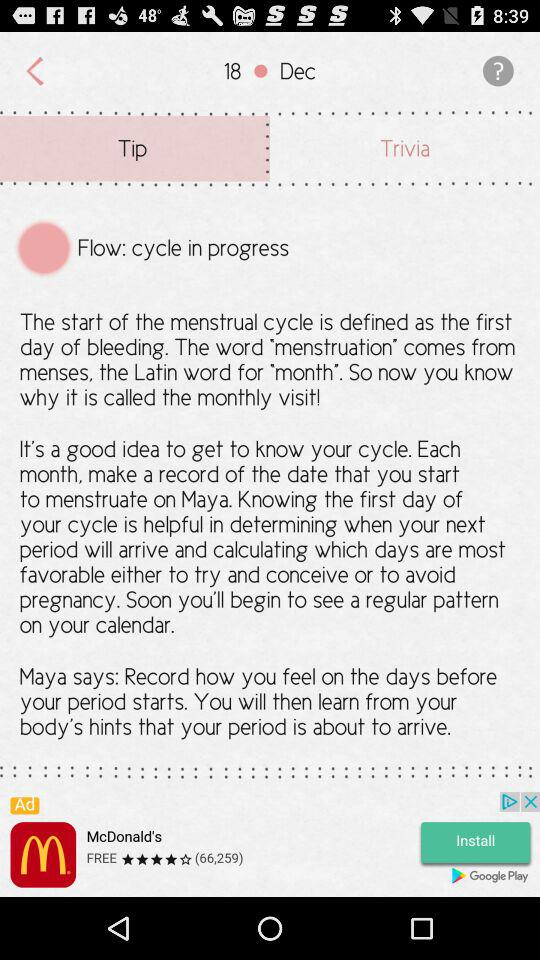What is the given date? The given date is December 20. 